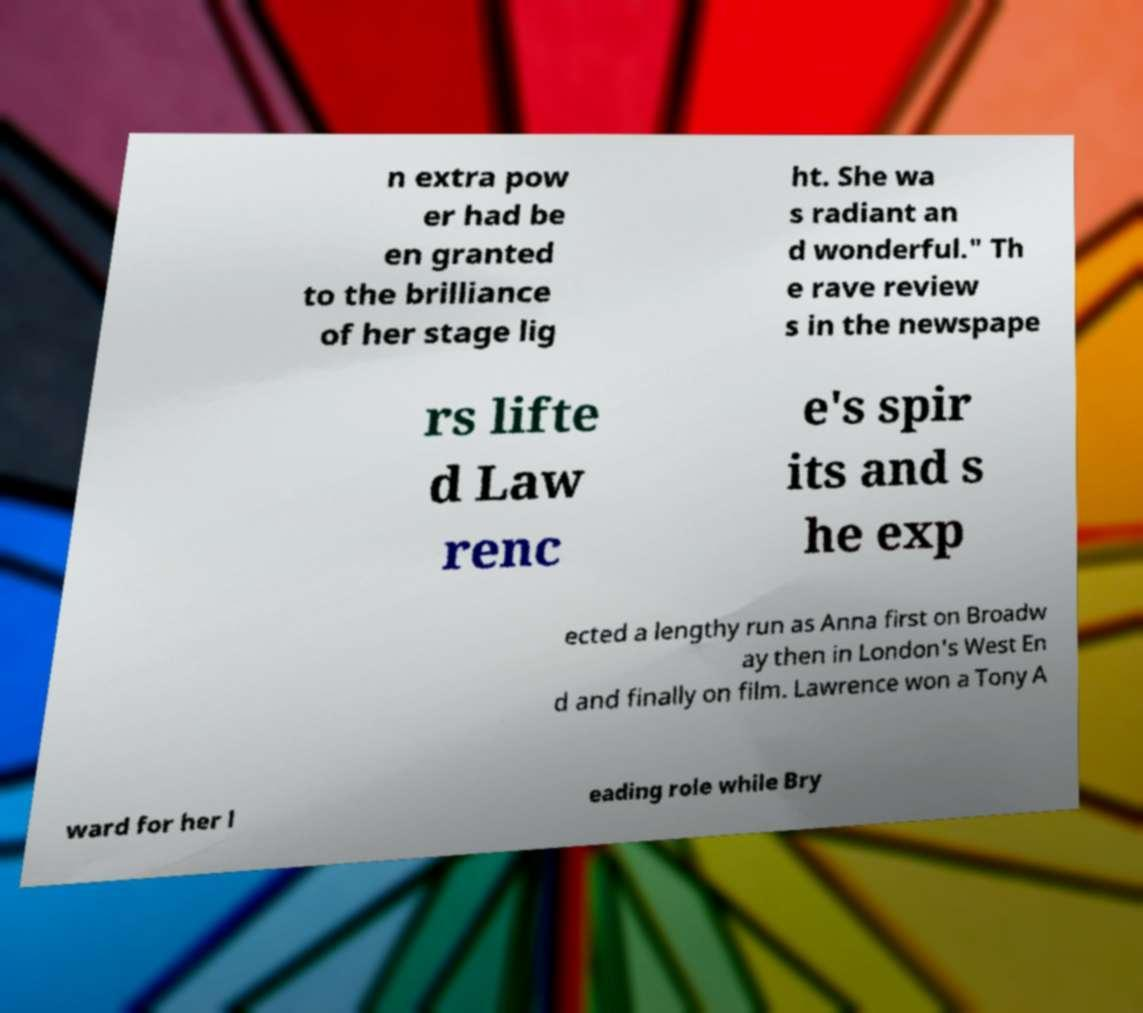What messages or text are displayed in this image? I need them in a readable, typed format. n extra pow er had be en granted to the brilliance of her stage lig ht. She wa s radiant an d wonderful." Th e rave review s in the newspape rs lifte d Law renc e's spir its and s he exp ected a lengthy run as Anna first on Broadw ay then in London's West En d and finally on film. Lawrence won a Tony A ward for her l eading role while Bry 